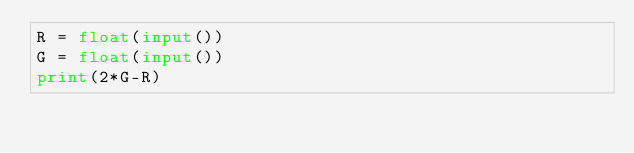Convert code to text. <code><loc_0><loc_0><loc_500><loc_500><_Python_>R = float(input())
G = float(input())
print(2*G-R)
</code> 